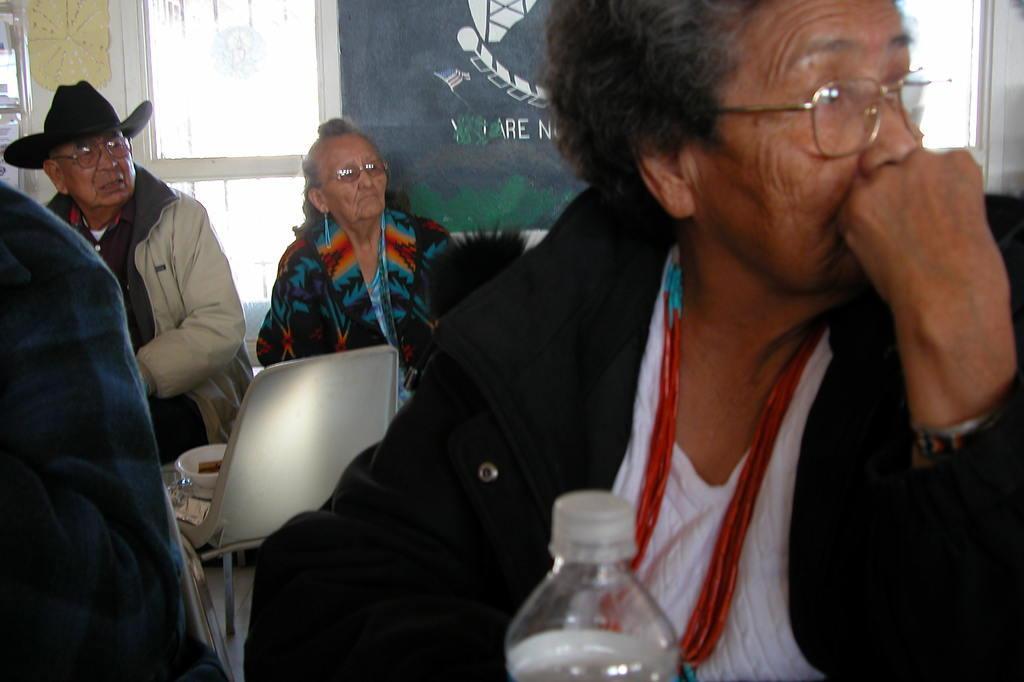Can you describe this image briefly? here we see a group people seated on the chairs 